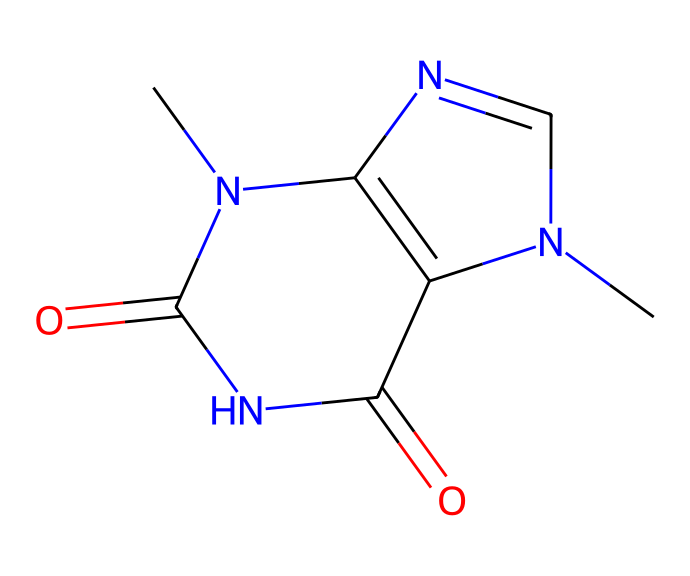What is the molecular formula of theobromine? By counting the carbon (C), hydrogen (H), nitrogen (N), and oxygen (O) atoms in the molecular structure represented by the SMILES, we find that the formula is C7H8N4O2.
Answer: C7H8N4O2 How many nitrogen atoms are present in theobromine? In the molecular structure of theobromine, we can identify four nitrogen atoms, deriving from the SMILES representation.
Answer: 4 What type of alkaloid is theobromine considered? Theobromine is categorized as a purine alkaloid, which is derived from its unique structure that includes a purine base.
Answer: purine alkaloid Which element contributes to the stimulating effect of theobromine? The nitrogen atoms in theobromine are responsible for its stimulating effects, as they are common in alkaloids and contribute to the biological activities of these compounds.
Answer: nitrogen What is the effect of theobromine on mood? Theobromine can enhance mood by acting as a mild stimulant and promoting feelings of well-being, typically attributed to its ability to increase dopamine and other neurotransmitters in the brain.
Answer: enhances mood 